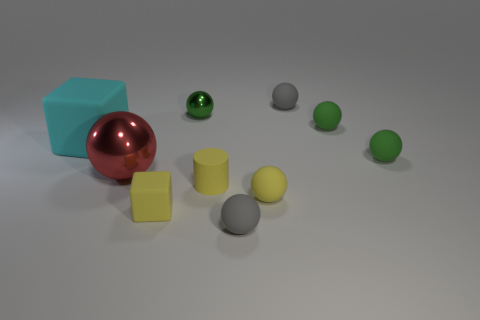Subtract all tiny green matte balls. How many balls are left? 5 Subtract 2 blocks. How many blocks are left? 0 Subtract all green spheres. How many spheres are left? 4 Subtract 1 yellow cylinders. How many objects are left? 9 Subtract all cubes. How many objects are left? 8 Subtract all green cylinders. Subtract all purple blocks. How many cylinders are left? 1 Subtract all cyan cubes. How many red spheres are left? 1 Subtract all yellow balls. Subtract all blue cylinders. How many objects are left? 9 Add 2 yellow matte balls. How many yellow matte balls are left? 3 Add 8 small gray shiny cylinders. How many small gray shiny cylinders exist? 8 